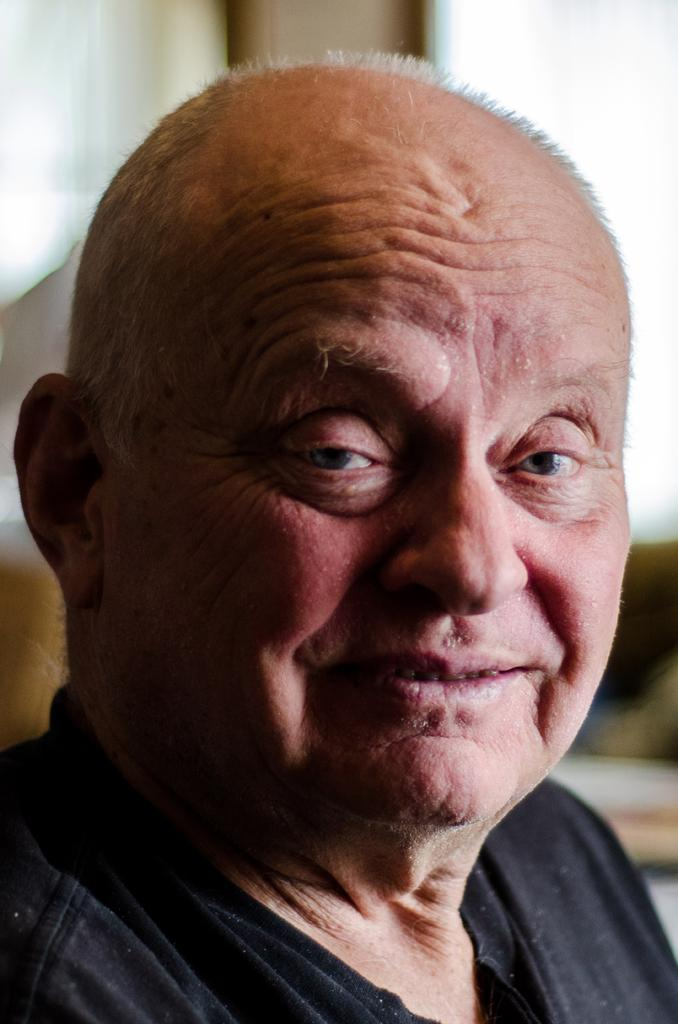What can be observed about the background of the image? The background of the image is blurred. Who is the main subject in the image? There is an old man in the image. What is the old man wearing? The old man is wearing black attire. What expression does the old man have? The old man is smiling. Can you see a screw on the old man's head in the image? No, there is no screw visible on the old man's head in the image. Is the old man wearing a crown in the image? No, the old man is not wearing a crown in the image; he is wearing black attire. 